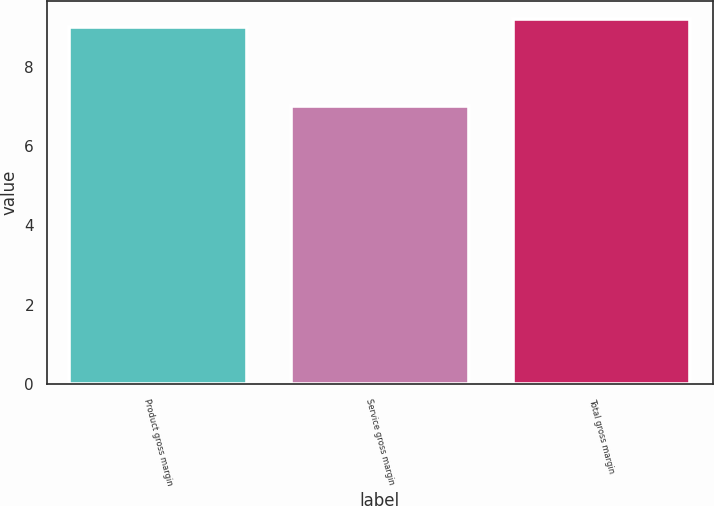<chart> <loc_0><loc_0><loc_500><loc_500><bar_chart><fcel>Product gross margin<fcel>Service gross margin<fcel>Total gross margin<nl><fcel>9<fcel>7<fcel>9.2<nl></chart> 